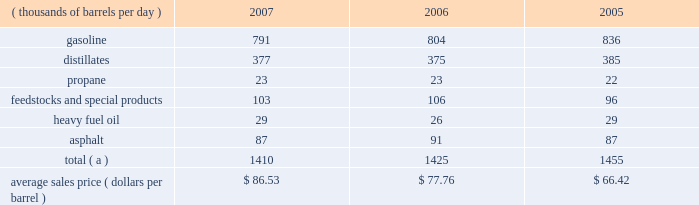Marketing we are a supplier of gasoline and distillates to resellers and consumers within our market area in the midwest , upper great plains , gulf coast and southeastern regions of the united states .
In 2007 , our refined products sales volumes totaled 21.6 billion gallons , or 1.410 mmbpd .
The average sales price of our refined products in aggregate was $ 86.53 per barrel for 2007 .
The table sets forth our refined products sales by product group and our average sales price for each of the last three years .
Refined product sales ( thousands of barrels per day ) 2007 2006 2005 .
Total ( a ) 1410 1425 1455 average sales price ( dollars per barrel ) $ 86.53 $ 77.76 $ 66.42 ( a ) includes matching buy/sell volumes of 24 mbpd and 77 mbpd in 2006 and 2005 .
On april 1 , 2006 , we changed our accounting for matching buy/sell arrangements as a result of a new accounting standard .
This change resulted in lower refined products sales volumes for 2007 and the remainder of 2006 than would have been reported under our previous accounting practices .
See note 2 to the consolidated financial statements .
The wholesale distribution of petroleum products to private brand marketers and to large commercial and industrial consumers and sales in the spot market accounted for 69 percent of our refined products sales volumes in 2007 .
We sold 49 percent of our gasoline volumes and 89 percent of our distillates volumes on a wholesale or spot market basis .
Half of our propane is sold into the home heating market , with the balance being purchased by industrial consumers .
Propylene , cumene , aromatics , aliphatics and sulfur are domestically marketed to customers in the chemical industry .
Base lube oils , maleic anhydride , slack wax , extract and pitch are sold throughout the united states and canada , with pitch products also being exported worldwide .
We market asphalt through owned and leased terminals throughout the midwest , upper great plains , gulf coast and southeastern regions of the united states .
Our customer base includes approximately 750 asphalt-paving contractors , government entities ( states , counties , cities and townships ) and asphalt roofing shingle manufacturers .
We have blended ethanol with gasoline for over 15 years and increased our blending program in 2007 , in part due to renewable fuel mandates .
We blended 41 mbpd of ethanol into gasoline in 2007 and 35 mbpd in both 2006 and 2005 .
The future expansion or contraction of our ethanol blending program will be driven by the economics of the ethanol supply and changes in government regulations .
We sell reformulated gasoline in parts of our marketing territory , primarily chicago , illinois ; louisville , kentucky ; northern kentucky ; milwaukee , wisconsin and hartford , illinois , and we sell low-vapor-pressure gasoline in nine states .
We also sell biodiesel in minnesota , illinois and kentucky .
As of december 31 , 2007 , we supplied petroleum products to about 4400 marathon branded-retail outlets located primarily in ohio , michigan , indiana , kentucky and illinois .
Branded retail outlets are also located in georgia , florida , minnesota , wisconsin , north carolina , tennessee , west virginia , virginia , south carolina , alabama , pennsylvania , and texas .
Sales to marathon-brand jobbers and dealers accounted for 16 percent of our refined product sales volumes in 2007 .
Speedway superamerica llc ( 201cssa 201d ) , our wholly-owned subsidiary , sells gasoline and diesel fuel primarily through retail outlets that we operate .
Sales of refined products through these ssa retail outlets accounted for 15 percent of our refined products sales volumes in 2007 .
As of december 31 , 2007 , ssa had 1636 retail outlets in nine states that sold petroleum products and convenience store merchandise and services , primarily under the brand names 201cspeedway 201d and 201csuperamerica . 201d ssa 2019s revenues from the sale of non-petroleum merchandise totaled $ 2.796 billion in 2007 , compared with $ 2.706 billion in 2006 .
Profit levels from the sale of such merchandise and services tend to be less volatile than profit levels from the retail sale of gasoline and diesel fuel .
Ssa also operates 59 valvoline instant oil change retail outlets located in michigan and northwest ohio .
Pilot travel centers llc ( 201cptc 201d ) , our joint venture with pilot corporation ( 201cpilot 201d ) , is the largest operator of travel centers in the united states with 286 locations in 37 states and canada at december 31 , 2007 .
The travel centers offer diesel fuel , gasoline and a variety of other services , including on-premises brand-name restaurants at many locations .
Pilot and marathon each own a 50 percent interest in ptc. .
Based on the average sales price listed above , how much did refined product sales increase from 2005 to 2007? 
Computations: ((1410 * 86.53) - (1455 * 66.42))
Answer: 25366.2. 